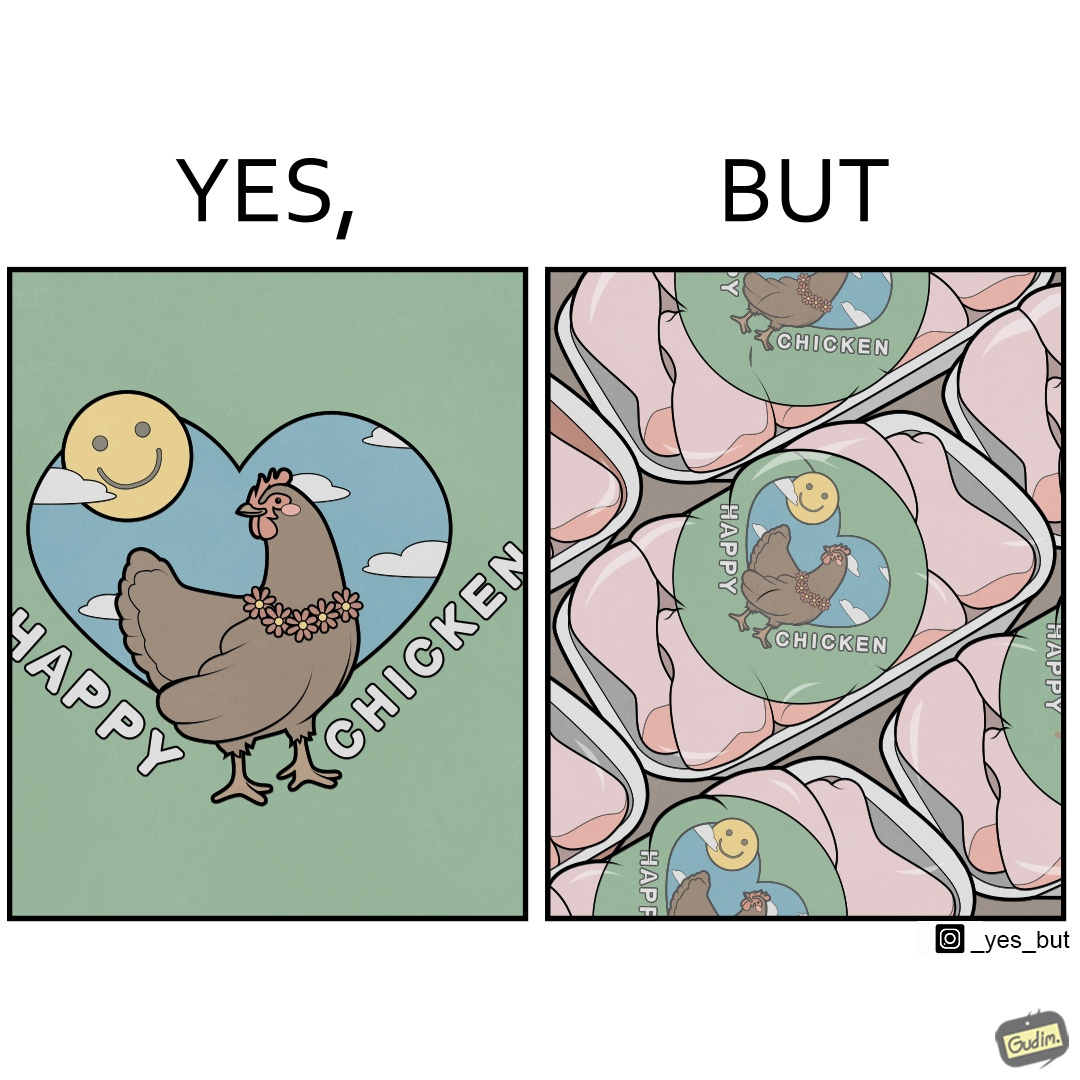What do you see in each half of this image? In the left part of the image: a chicken with a quote "HAPPY CHICKEN" in the background In the right part of the image: chicken pieces packed in boxes with a logo of a chicken with name "HAPPY CHICKEN" printed on it 